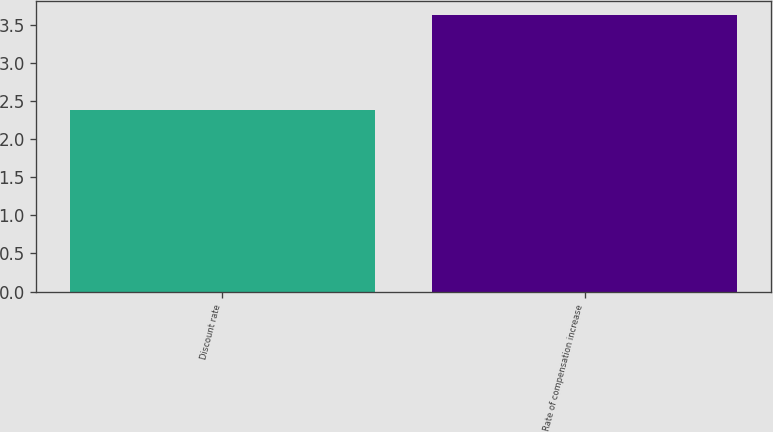<chart> <loc_0><loc_0><loc_500><loc_500><bar_chart><fcel>Discount rate<fcel>Rate of compensation increase<nl><fcel>2.38<fcel>3.63<nl></chart> 